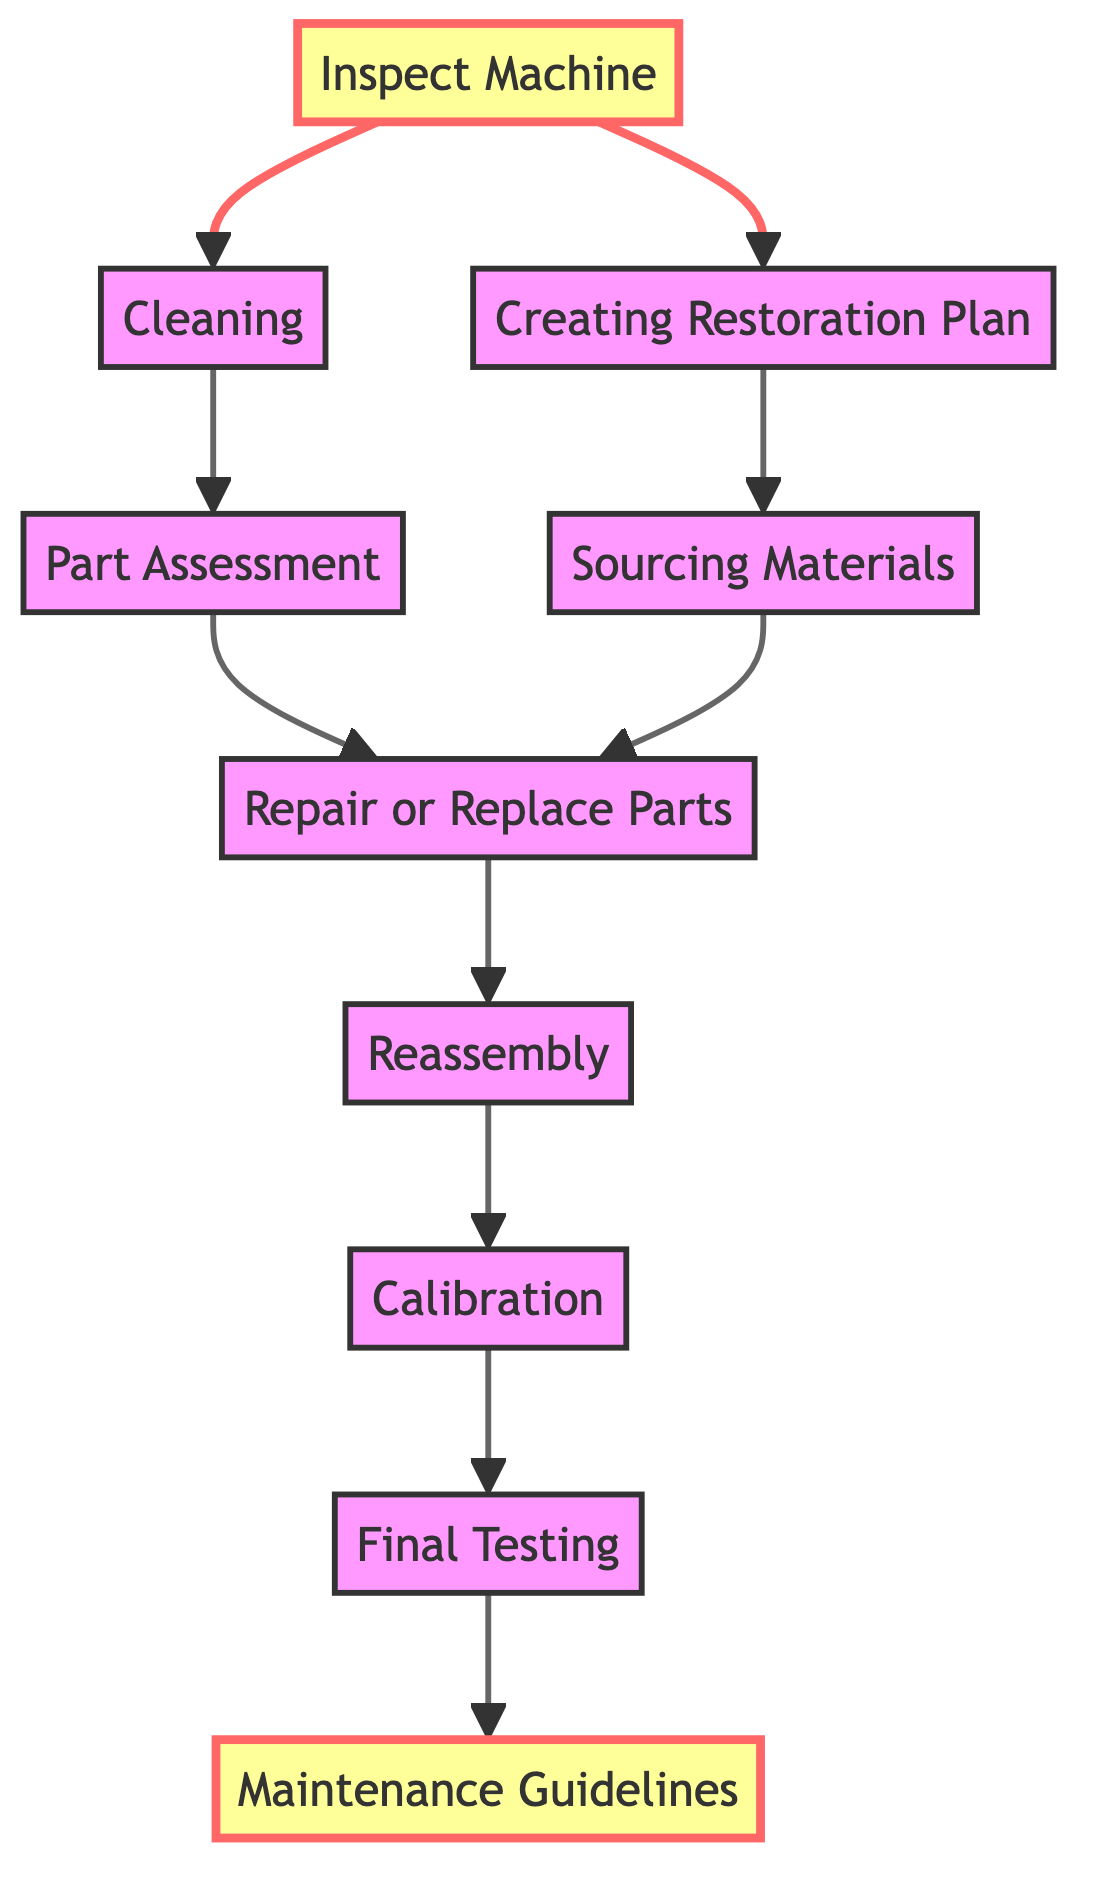What is the first step in the process? The diagram starts with "Inspect Machine" as the first step in the restoration and maintenance process.
Answer: Inspect Machine How many main steps are there in the diagram? The diagram has 10 main steps, with each step representing a node in the flow.
Answer: 10 What action follows the cleaning of the machine? After the "Cleaning" step, the next action is "Part Assessment."
Answer: Part Assessment Which step involves procuring necessary materials? The step "Sourcing Materials" involves finding and procuring necessary materials for restoration.
Answer: Sourcing Materials What is the final step in the restoration process? The last action in the flow is "Maintenance Guidelines," which documents regular maintenance practices.
Answer: Maintenance Guidelines What steps are initiated after "Inspect Machine"? The "Inspect Machine" step leads to two actions: "Cleaning" and "Creating Restoration Plan."
Answer: Cleaning and Creating Restoration Plan What step follows both "Part Assessment" and "Sourcing Materials"? Both "Part Assessment" and "Sourcing Materials" lead to the same next step, which is "Repair or Replace Parts."
Answer: Repair or Replace Parts How is the machine verified for correct operation? The "Final Testing" step is responsible for verifying that the machine operates correctly.
Answer: Final Testing What does "Calibration" ensure? The "Calibration" step ensures accurate and efficient operation of the machine post-restoration.
Answer: Accurate and efficient operation 